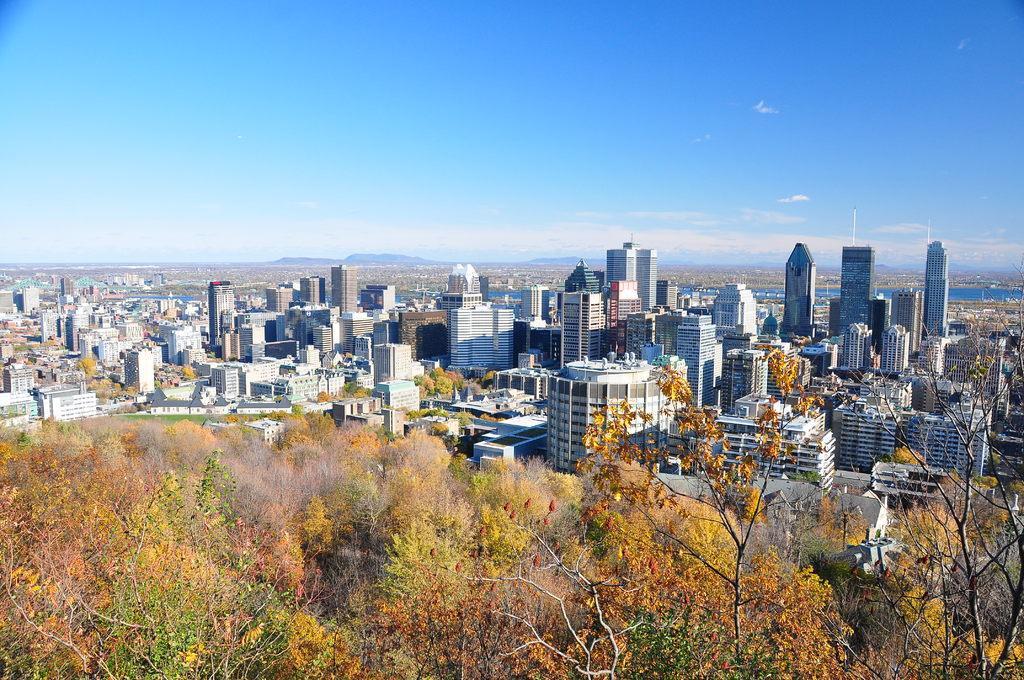Please provide a concise description of this image. In this picture we can see few trees and buildings, in the background we can find water, few hills and clouds. 